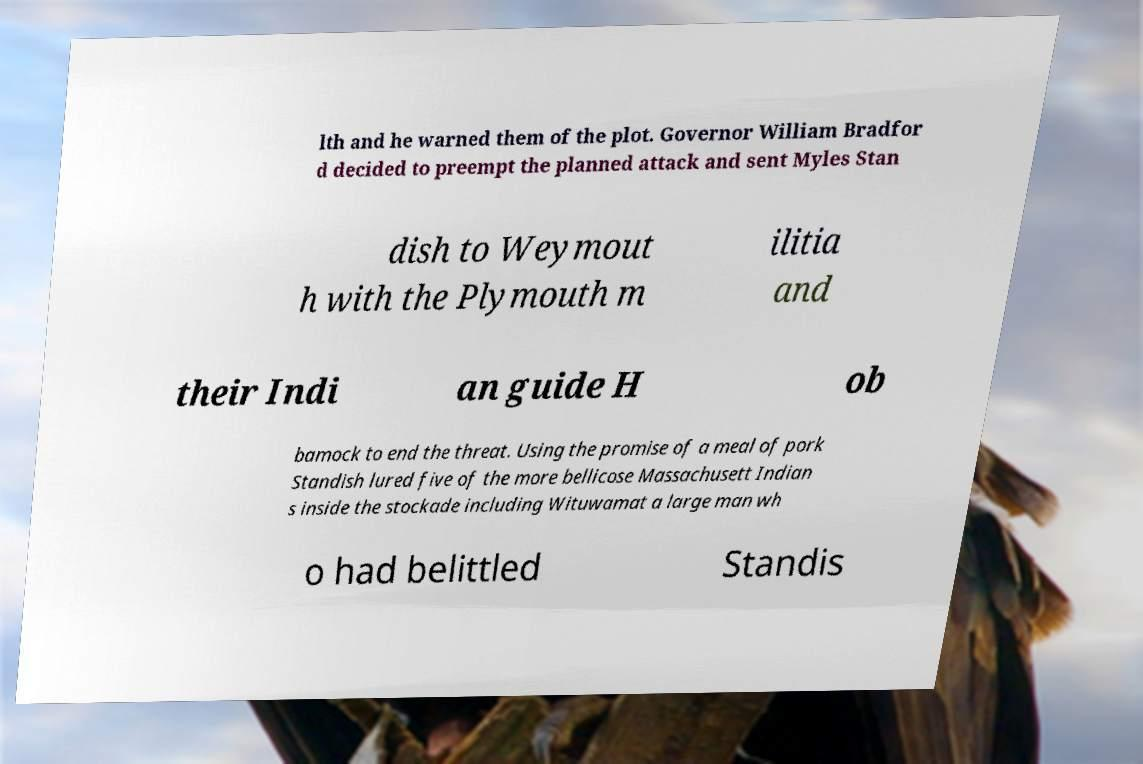Please read and relay the text visible in this image. What does it say? lth and he warned them of the plot. Governor William Bradfor d decided to preempt the planned attack and sent Myles Stan dish to Weymout h with the Plymouth m ilitia and their Indi an guide H ob bamock to end the threat. Using the promise of a meal of pork Standish lured five of the more bellicose Massachusett Indian s inside the stockade including Wituwamat a large man wh o had belittled Standis 